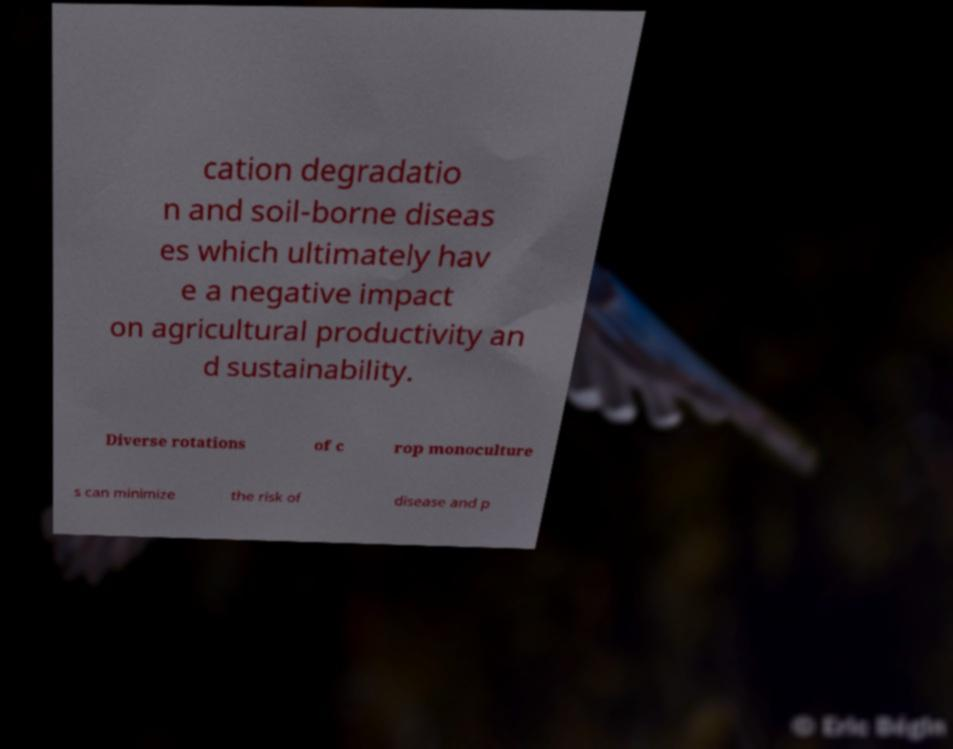Please identify and transcribe the text found in this image. cation degradatio n and soil-borne diseas es which ultimately hav e a negative impact on agricultural productivity an d sustainability. Diverse rotations of c rop monoculture s can minimize the risk of disease and p 